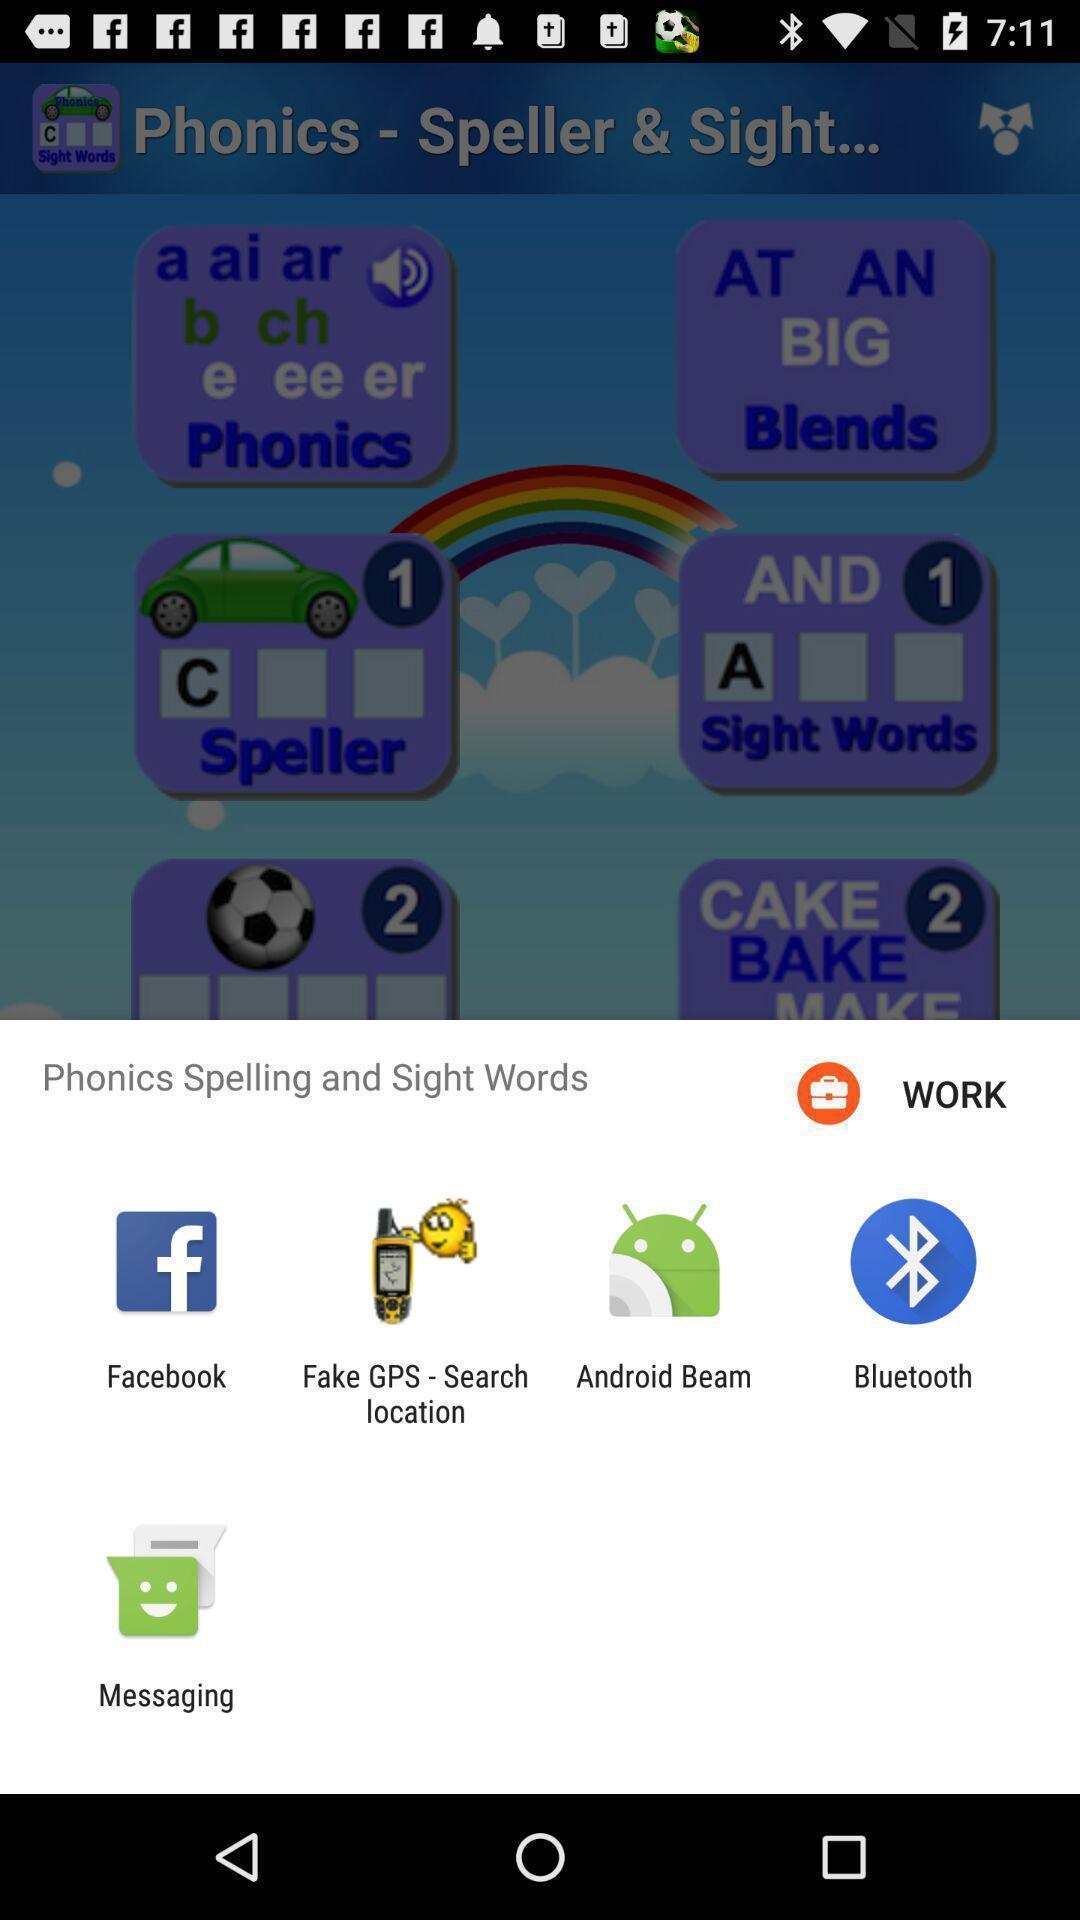Give me a summary of this screen capture. Set of sharing options menu. 